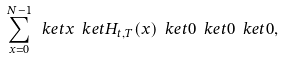Convert formula to latex. <formula><loc_0><loc_0><loc_500><loc_500>\sum _ { x = 0 } ^ { N - 1 } \ k e t { x } \ k e t { H _ { t , T } ( x ) } \ k e t { 0 } \ k e t { 0 } \ k e t { 0 } ,</formula> 